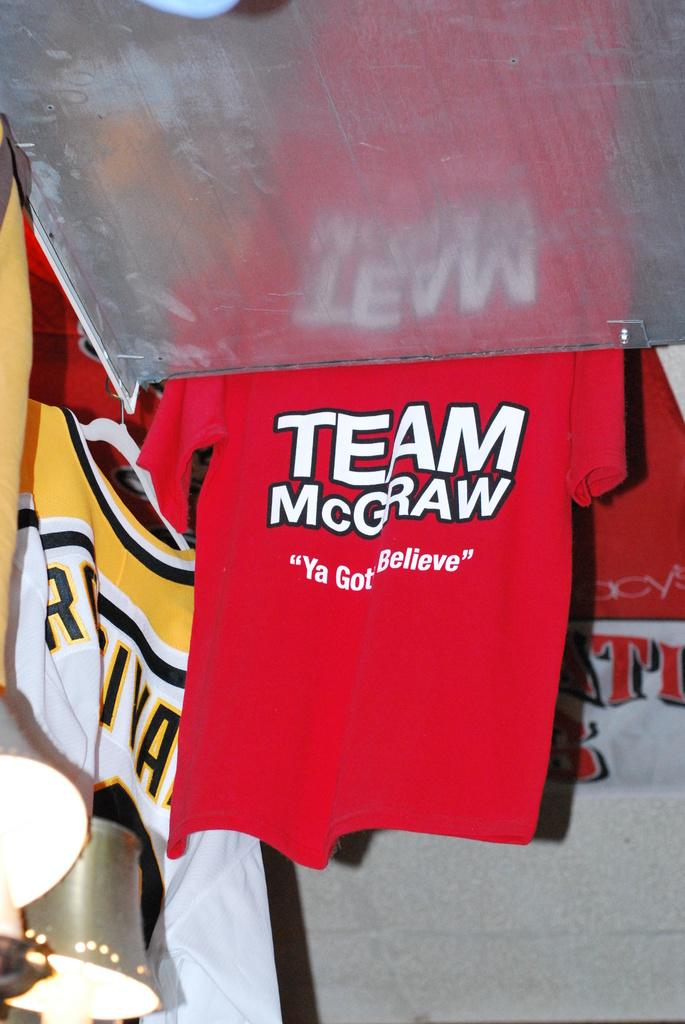<image>
Summarize the visual content of the image. T-shirts hanging, one in red says TEAM McGraw "Ya Gotta Believe". 